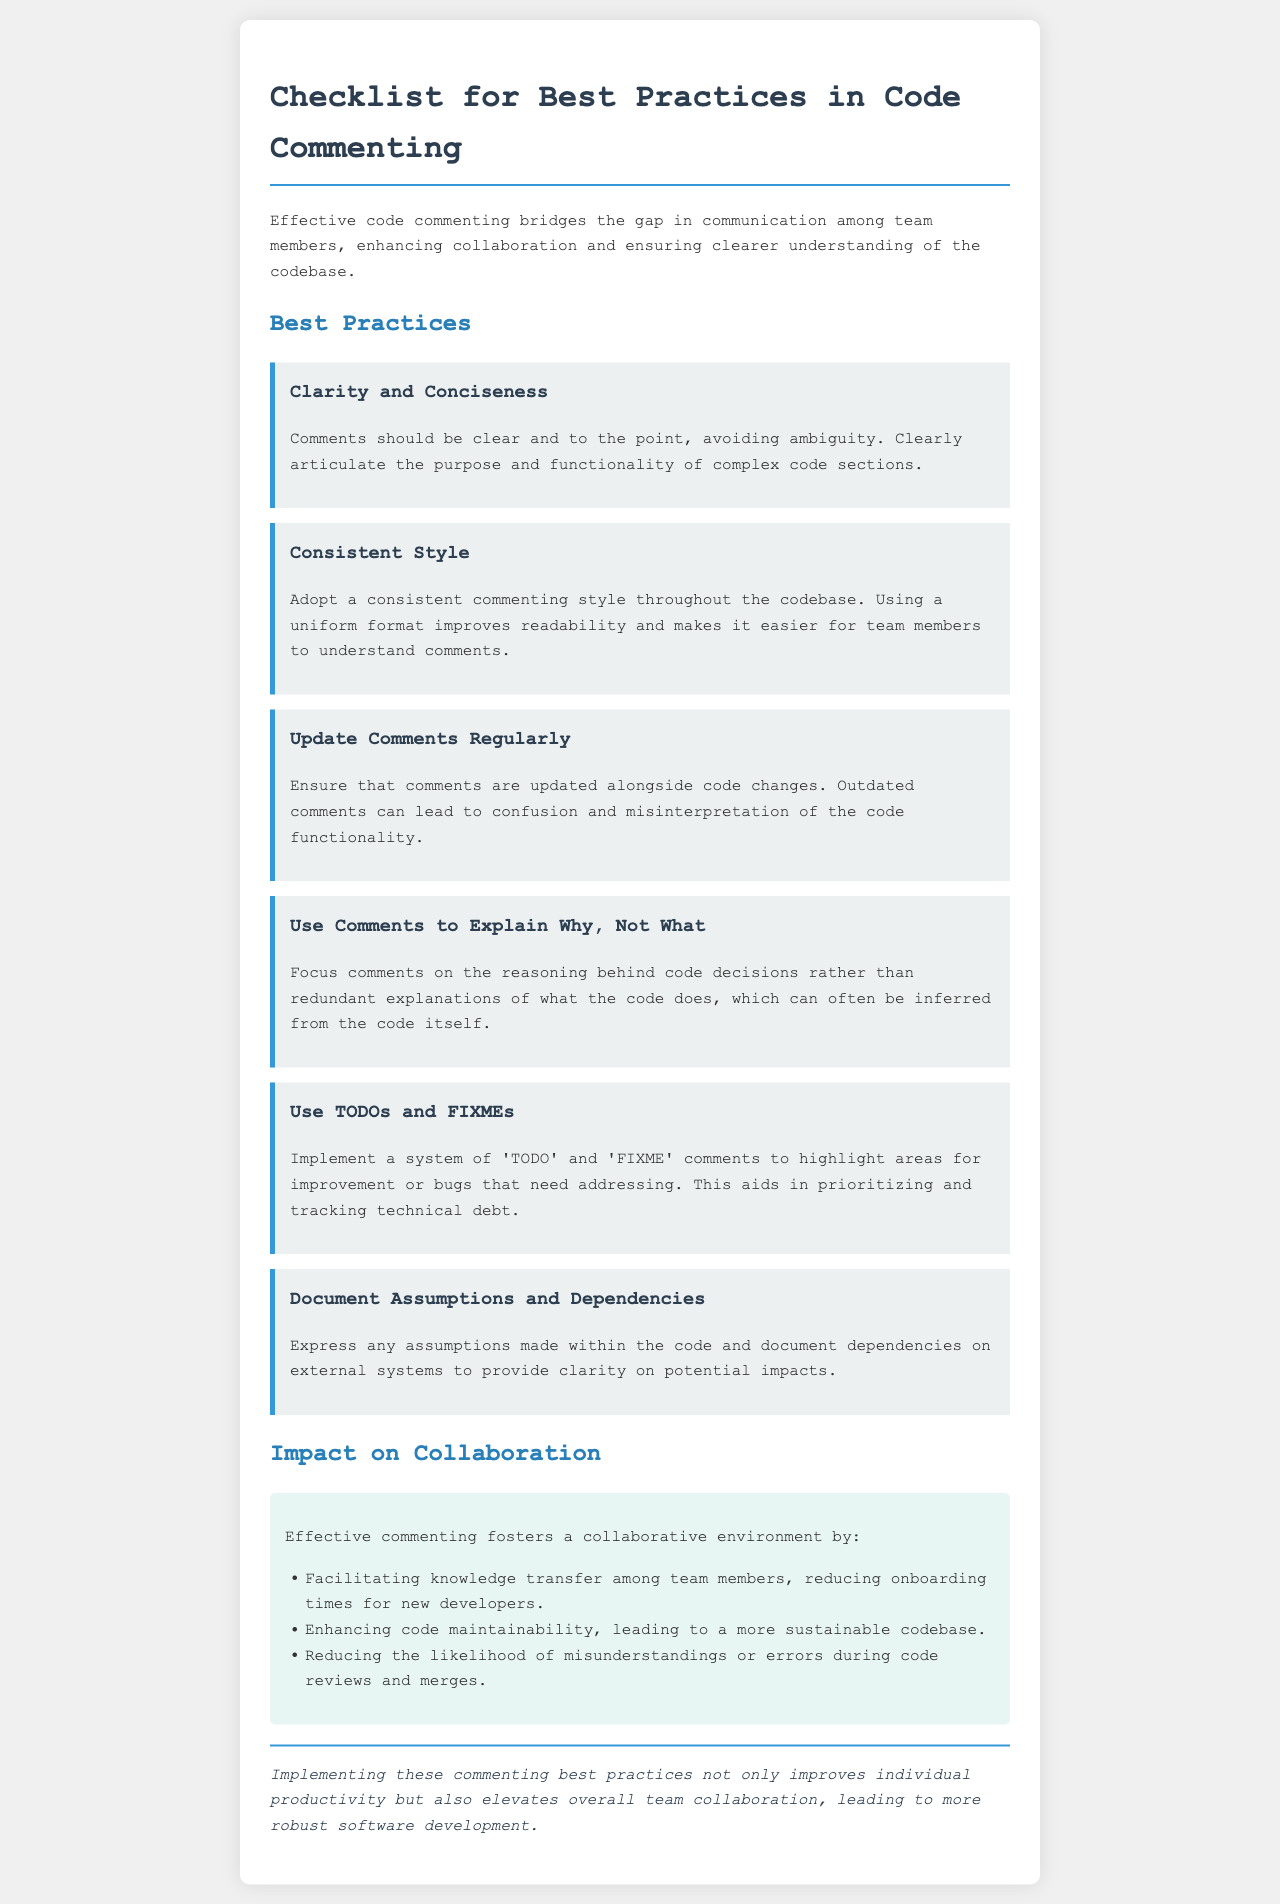what is the title of the document? The title is indicated in the document's head section, which is "Code Commenting Best Practices."
Answer: Code Commenting Best Practices how many best practices are listed? The document lists six distinct best practices related to code commenting.
Answer: six what is one recommended style for commenting? The document emphasizes the importance of a consistent commenting style throughout the codebase.
Answer: consistent style what does the document suggest using to highlight areas for improvement? The document mentions using 'TODO' and 'FIXME' comments as a method to track improvements or bugs.
Answer: TODOs and FIXMEs what is one impact of effective commenting on collaboration? One of the impacts mentioned is that effective commenting facilitates knowledge transfer among team members.
Answer: facilitates knowledge transfer why should comments be updated regularly? The document states that outdated comments can lead to confusion and misinterpretation of the code functionality.
Answer: confusion and misinterpretation what is the conclusion of the document? The document concludes that implementing commenting best practices improves individual productivity and team collaboration.
Answer: improves individual productivity and team collaboration 